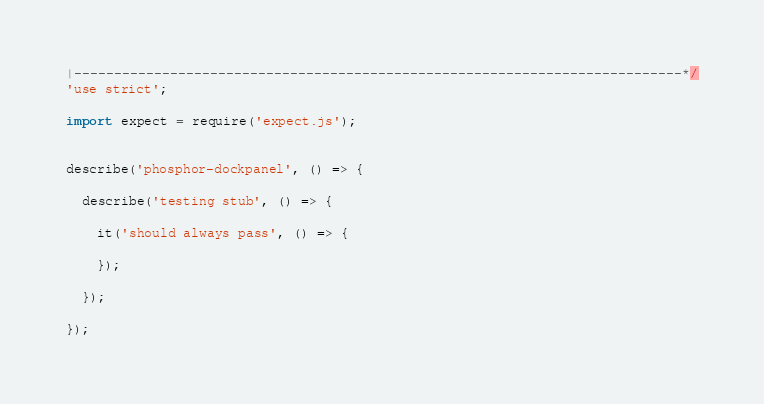<code> <loc_0><loc_0><loc_500><loc_500><_TypeScript_>|----------------------------------------------------------------------------*/
'use strict';

import expect = require('expect.js');


describe('phosphor-dockpanel', () => {

  describe('testing stub', () => {

    it('should always pass', () => {

    });

  });

});
</code> 